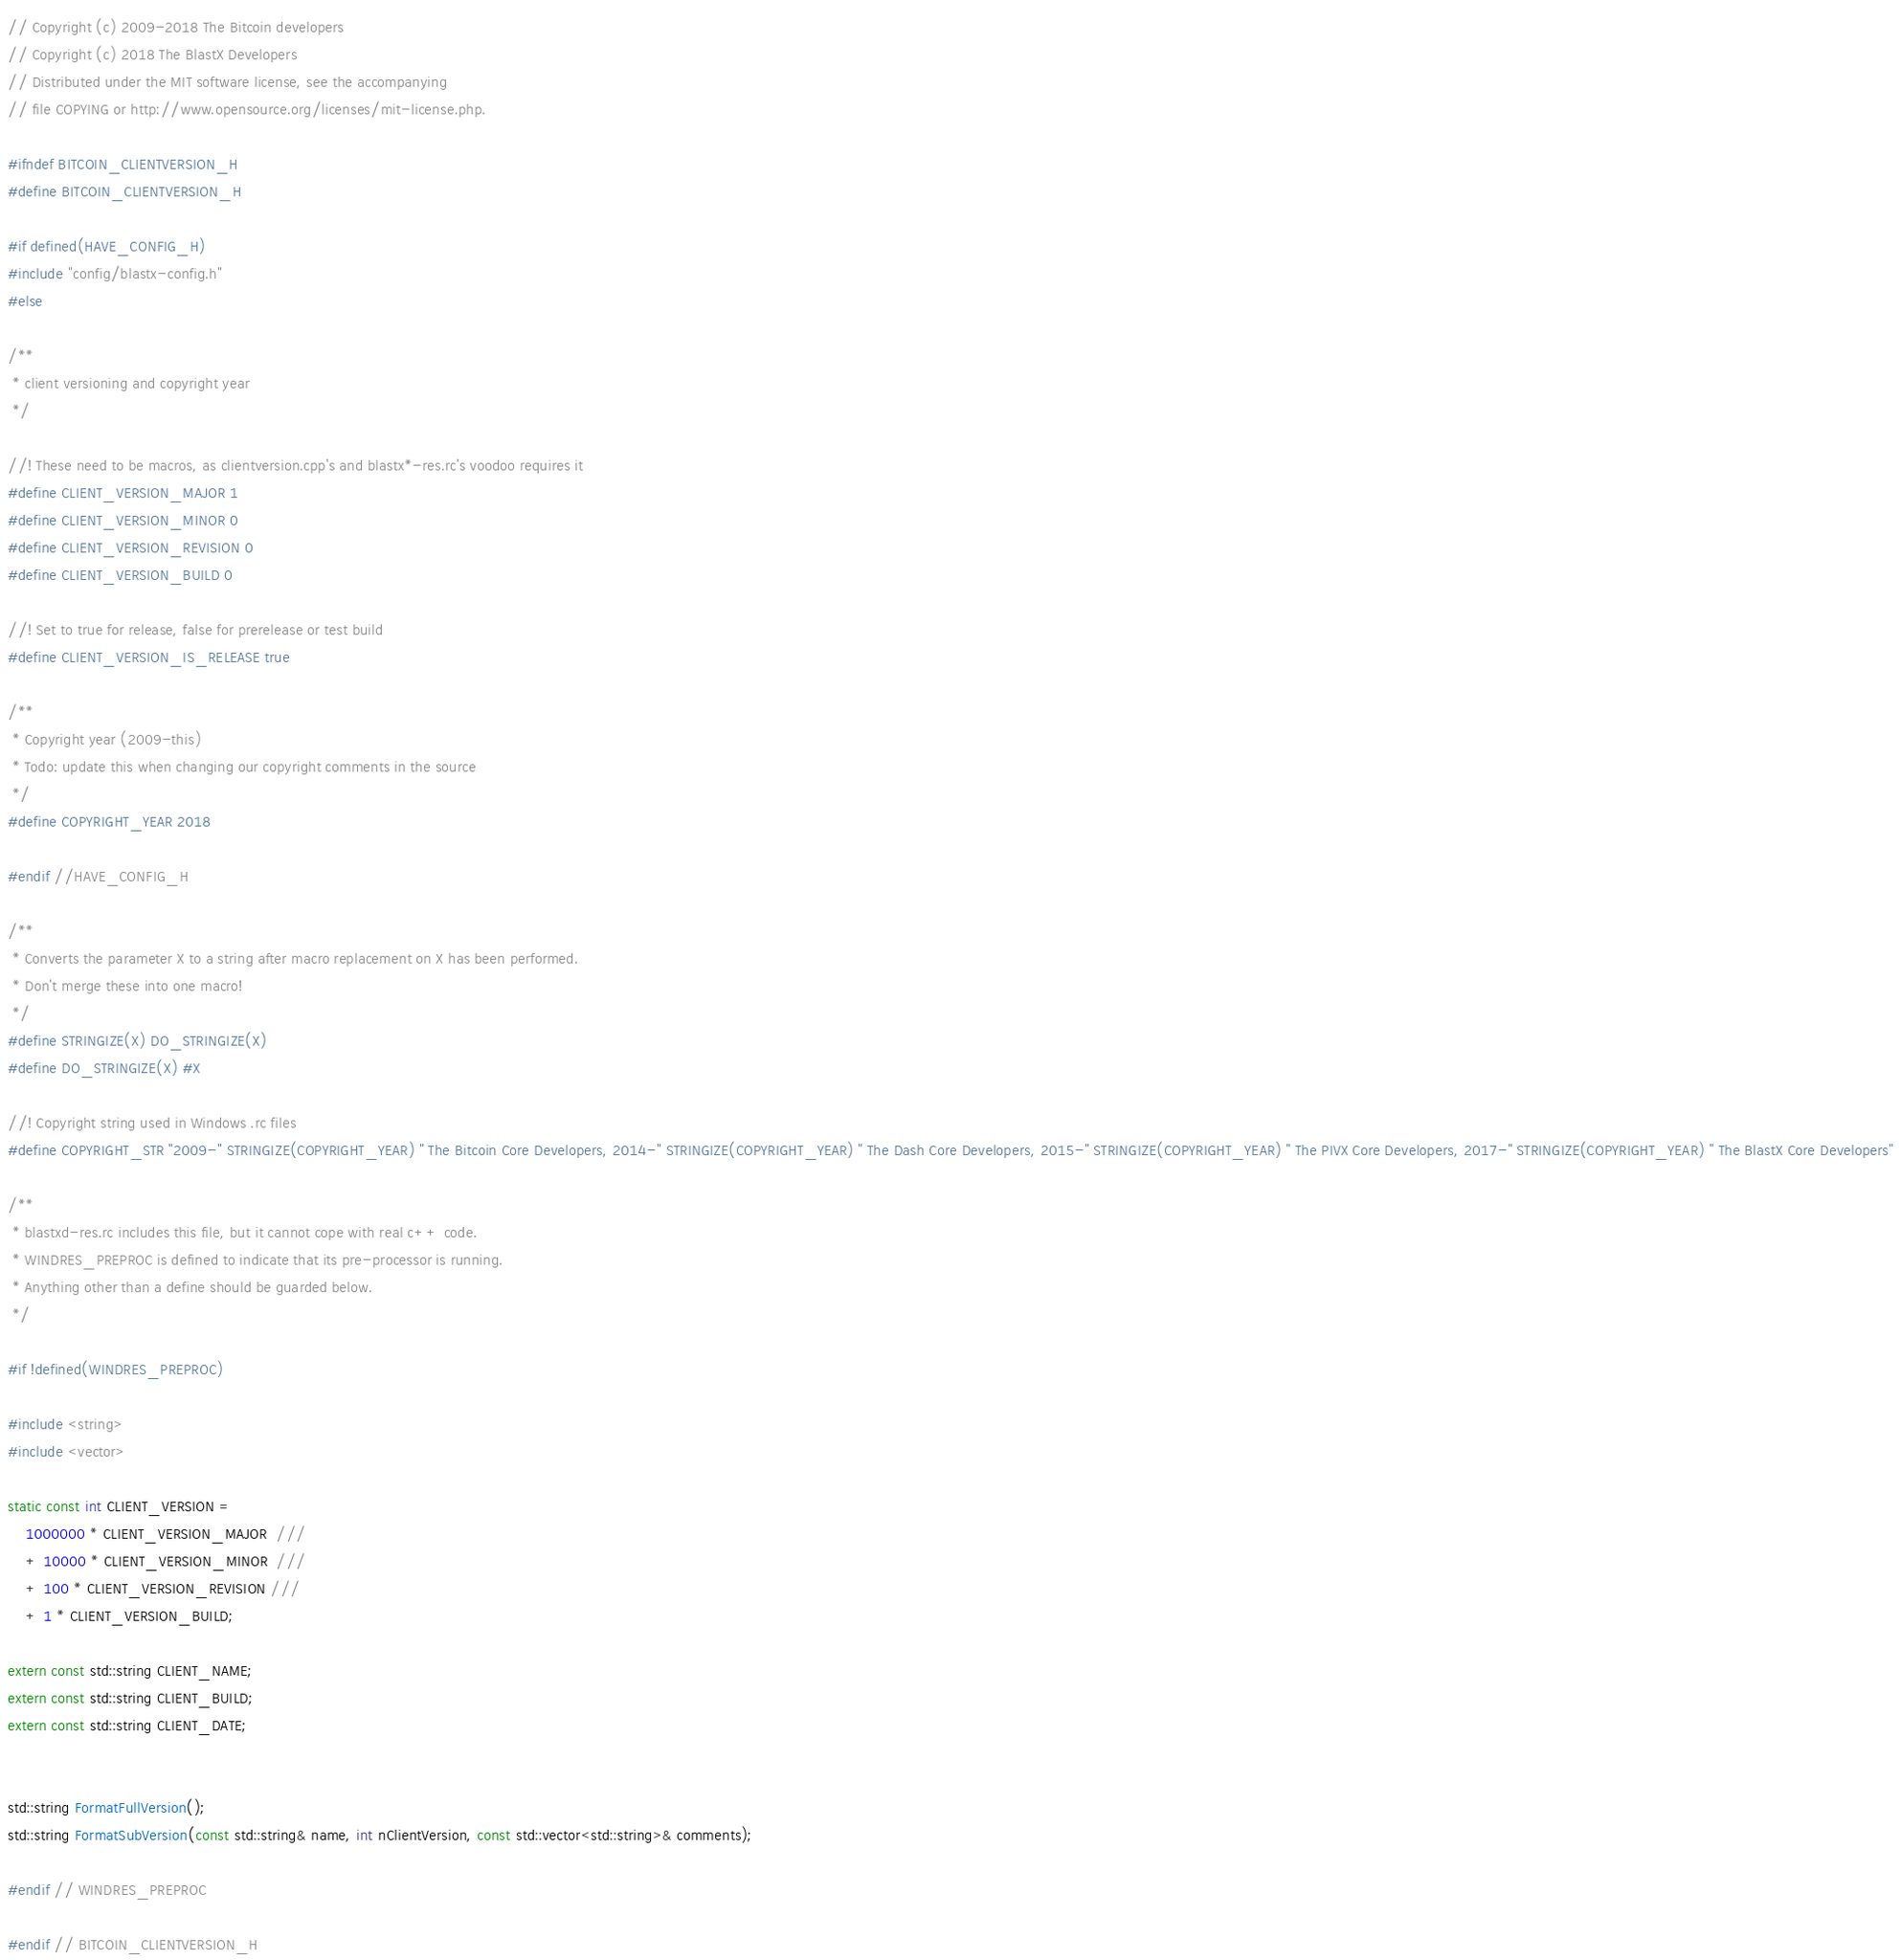<code> <loc_0><loc_0><loc_500><loc_500><_C_>// Copyright (c) 2009-2018 The Bitcoin developers
// Copyright (c) 2018 The BlastX Developers
// Distributed under the MIT software license, see the accompanying
// file COPYING or http://www.opensource.org/licenses/mit-license.php.

#ifndef BITCOIN_CLIENTVERSION_H
#define BITCOIN_CLIENTVERSION_H

#if defined(HAVE_CONFIG_H)
#include "config/blastx-config.h"
#else

/**
 * client versioning and copyright year
 */

//! These need to be macros, as clientversion.cpp's and blastx*-res.rc's voodoo requires it
#define CLIENT_VERSION_MAJOR 1
#define CLIENT_VERSION_MINOR 0
#define CLIENT_VERSION_REVISION 0
#define CLIENT_VERSION_BUILD 0

//! Set to true for release, false for prerelease or test build
#define CLIENT_VERSION_IS_RELEASE true

/**
 * Copyright year (2009-this)
 * Todo: update this when changing our copyright comments in the source
 */
#define COPYRIGHT_YEAR 2018

#endif //HAVE_CONFIG_H

/**
 * Converts the parameter X to a string after macro replacement on X has been performed.
 * Don't merge these into one macro!
 */
#define STRINGIZE(X) DO_STRINGIZE(X)
#define DO_STRINGIZE(X) #X

//! Copyright string used in Windows .rc files
#define COPYRIGHT_STR "2009-" STRINGIZE(COPYRIGHT_YEAR) " The Bitcoin Core Developers, 2014-" STRINGIZE(COPYRIGHT_YEAR) " The Dash Core Developers, 2015-" STRINGIZE(COPYRIGHT_YEAR) " The PIVX Core Developers, 2017-" STRINGIZE(COPYRIGHT_YEAR) " The BlastX Core Developers"

/**
 * blastxd-res.rc includes this file, but it cannot cope with real c++ code.
 * WINDRES_PREPROC is defined to indicate that its pre-processor is running.
 * Anything other than a define should be guarded below.
 */

#if !defined(WINDRES_PREPROC)

#include <string>
#include <vector>

static const int CLIENT_VERSION =
    1000000 * CLIENT_VERSION_MAJOR  ///
    + 10000 * CLIENT_VERSION_MINOR  ///
    + 100 * CLIENT_VERSION_REVISION ///
    + 1 * CLIENT_VERSION_BUILD;

extern const std::string CLIENT_NAME;
extern const std::string CLIENT_BUILD;
extern const std::string CLIENT_DATE;


std::string FormatFullVersion();
std::string FormatSubVersion(const std::string& name, int nClientVersion, const std::vector<std::string>& comments);

#endif // WINDRES_PREPROC

#endif // BITCOIN_CLIENTVERSION_H
</code> 